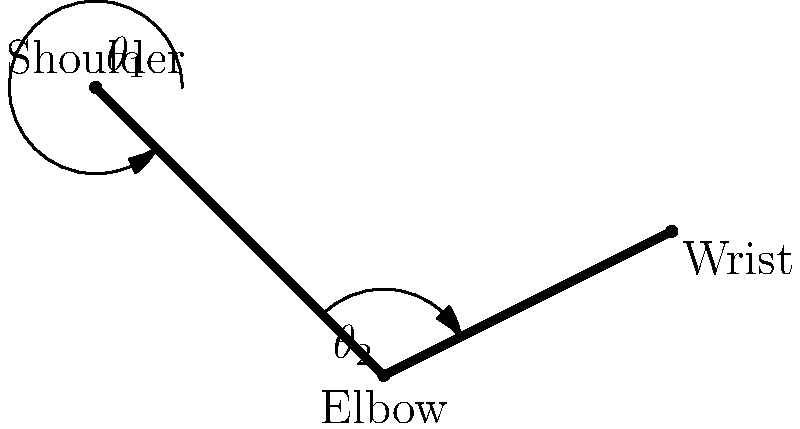Given the stick figure diagram of a human arm during a lifting motion, calculate the elbow angle ($\theta_2$) using the coordinates of the shoulder (0,0), elbow (1,-1), and wrist (2,-0.5). Round your answer to the nearest degree. To calculate the elbow angle, we'll use vector operations and the dot product formula. Here's a step-by-step approach:

1. Define vectors:
   Upper arm vector: $\vec{a} = (1,-1) - (0,0) = (1,-1)$
   Forearm vector: $\vec{b} = (2,-0.5) - (1,-1) = (1,0.5)$

2. Calculate dot product:
   $\vec{a} \cdot \vec{b} = (1)(1) + (-1)(0.5) = 0.5$

3. Calculate magnitudes:
   $|\vec{a}| = \sqrt{1^2 + (-1)^2} = \sqrt{2}$
   $|\vec{b}| = \sqrt{1^2 + 0.5^2} = \sqrt{1.25}$

4. Use the dot product formula:
   $\cos(\theta) = \frac{\vec{a} \cdot \vec{b}}{|\vec{a}||\vec{b}|}$

5. Substitute values:
   $\cos(\theta) = \frac{0.5}{\sqrt{2}\sqrt{1.25}} = \frac{0.5}{\sqrt{2.5}}$

6. Calculate the angle:
   $\theta = \arccos(\frac{0.5}{\sqrt{2.5}}) \approx 1.2490$ radians

7. Convert to degrees:
   $\theta \approx 1.2490 \times \frac{180}{\pi} \approx 71.57°$

8. Round to the nearest degree:
   $\theta \approx 72°$

The elbow angle ($\theta_2$) is approximately 72°.
Answer: 72° 